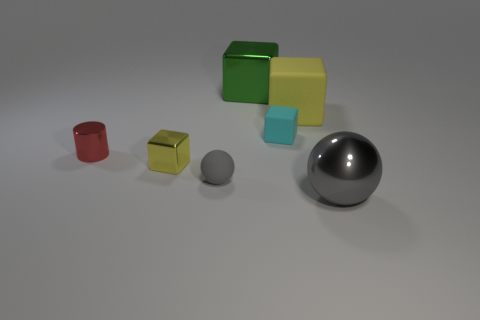Is the color of the matte sphere the same as the large metal sphere?
Make the answer very short. Yes. What size is the green thing?
Offer a very short reply. Large. The gray object that is made of the same material as the cyan cube is what size?
Keep it short and to the point. Small. There is a green cube that is behind the yellow metal block; is its size the same as the tiny yellow object?
Ensure brevity in your answer.  No. What shape is the gray object behind the sphere that is right of the big yellow rubber cube behind the tiny cyan object?
Provide a succinct answer. Sphere. What number of objects are either small yellow things or objects that are in front of the tiny cyan rubber thing?
Make the answer very short. 4. What size is the yellow block that is behind the red cylinder?
Give a very brief answer. Large. The rubber object that is the same color as the metal sphere is what shape?
Provide a succinct answer. Sphere. Are the green object and the yellow thing that is behind the tiny rubber block made of the same material?
Your answer should be compact. No. What number of small gray rubber spheres are on the left side of the large thing on the right side of the matte object that is right of the cyan cube?
Offer a very short reply. 1. 